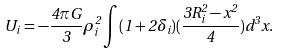<formula> <loc_0><loc_0><loc_500><loc_500>U _ { i } = - \frac { 4 \pi G } { 3 } \rho _ { i } ^ { 2 } \int ( 1 + 2 \delta _ { i } ) ( \frac { 3 R _ { i } ^ { 2 } - x ^ { 2 } } { 4 } ) d ^ { 3 } x .</formula> 